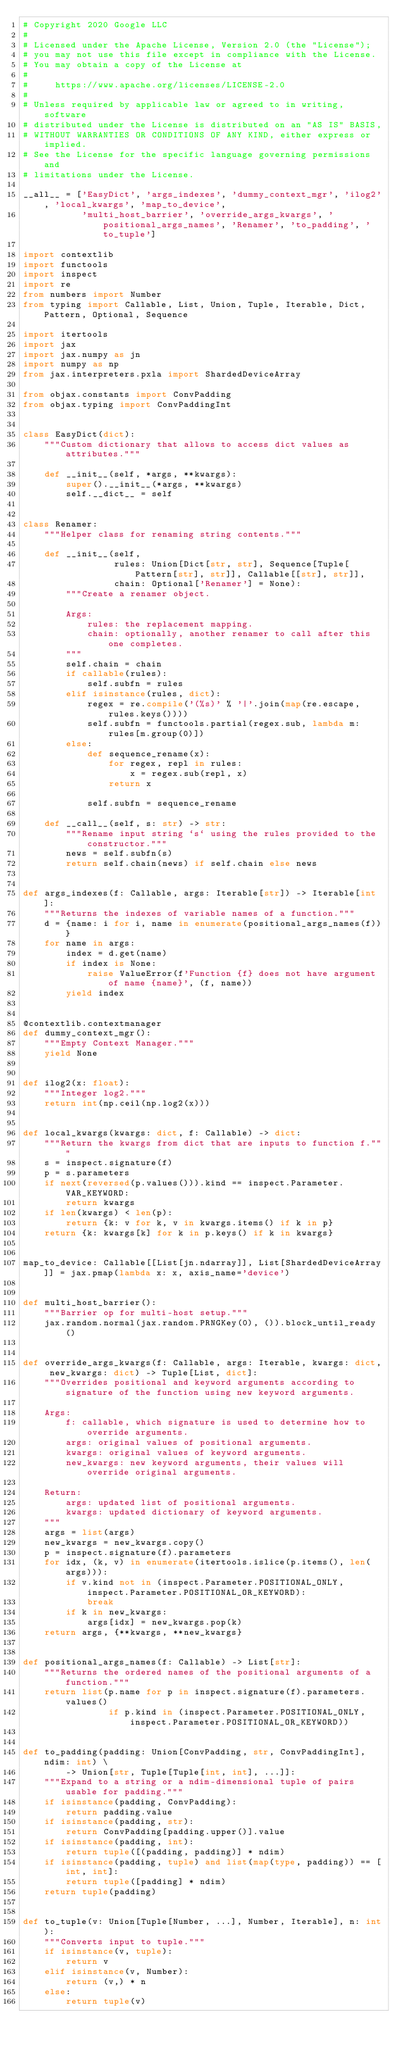Convert code to text. <code><loc_0><loc_0><loc_500><loc_500><_Python_># Copyright 2020 Google LLC
#
# Licensed under the Apache License, Version 2.0 (the "License");
# you may not use this file except in compliance with the License.
# You may obtain a copy of the License at
#
#     https://www.apache.org/licenses/LICENSE-2.0
#
# Unless required by applicable law or agreed to in writing, software
# distributed under the License is distributed on an "AS IS" BASIS,
# WITHOUT WARRANTIES OR CONDITIONS OF ANY KIND, either express or implied.
# See the License for the specific language governing permissions and
# limitations under the License.

__all__ = ['EasyDict', 'args_indexes', 'dummy_context_mgr', 'ilog2', 'local_kwargs', 'map_to_device',
           'multi_host_barrier', 'override_args_kwargs', 'positional_args_names', 'Renamer', 'to_padding', 'to_tuple']

import contextlib
import functools
import inspect
import re
from numbers import Number
from typing import Callable, List, Union, Tuple, Iterable, Dict, Pattern, Optional, Sequence

import itertools
import jax
import jax.numpy as jn
import numpy as np
from jax.interpreters.pxla import ShardedDeviceArray

from objax.constants import ConvPadding
from objax.typing import ConvPaddingInt


class EasyDict(dict):
    """Custom dictionary that allows to access dict values as attributes."""

    def __init__(self, *args, **kwargs):
        super().__init__(*args, **kwargs)
        self.__dict__ = self


class Renamer:
    """Helper class for renaming string contents."""

    def __init__(self,
                 rules: Union[Dict[str, str], Sequence[Tuple[Pattern[str], str]], Callable[[str], str]],
                 chain: Optional['Renamer'] = None):
        """Create a renamer object.

        Args:
            rules: the replacement mapping.
            chain: optionally, another renamer to call after this one completes.
        """
        self.chain = chain
        if callable(rules):
            self.subfn = rules
        elif isinstance(rules, dict):
            regex = re.compile('(%s)' % '|'.join(map(re.escape, rules.keys())))
            self.subfn = functools.partial(regex.sub, lambda m: rules[m.group(0)])
        else:
            def sequence_rename(x):
                for regex, repl in rules:
                    x = regex.sub(repl, x)
                return x

            self.subfn = sequence_rename

    def __call__(self, s: str) -> str:
        """Rename input string `s` using the rules provided to the constructor."""
        news = self.subfn(s)
        return self.chain(news) if self.chain else news


def args_indexes(f: Callable, args: Iterable[str]) -> Iterable[int]:
    """Returns the indexes of variable names of a function."""
    d = {name: i for i, name in enumerate(positional_args_names(f))}
    for name in args:
        index = d.get(name)
        if index is None:
            raise ValueError(f'Function {f} does not have argument of name {name}', (f, name))
        yield index


@contextlib.contextmanager
def dummy_context_mgr():
    """Empty Context Manager."""
    yield None


def ilog2(x: float):
    """Integer log2."""
    return int(np.ceil(np.log2(x)))


def local_kwargs(kwargs: dict, f: Callable) -> dict:
    """Return the kwargs from dict that are inputs to function f."""
    s = inspect.signature(f)
    p = s.parameters
    if next(reversed(p.values())).kind == inspect.Parameter.VAR_KEYWORD:
        return kwargs
    if len(kwargs) < len(p):
        return {k: v for k, v in kwargs.items() if k in p}
    return {k: kwargs[k] for k in p.keys() if k in kwargs}


map_to_device: Callable[[List[jn.ndarray]], List[ShardedDeviceArray]] = jax.pmap(lambda x: x, axis_name='device')


def multi_host_barrier():
    """Barrier op for multi-host setup."""
    jax.random.normal(jax.random.PRNGKey(0), ()).block_until_ready()


def override_args_kwargs(f: Callable, args: Iterable, kwargs: dict, new_kwargs: dict) -> Tuple[List, dict]:
    """Overrides positional and keyword arguments according to signature of the function using new keyword arguments.

    Args:
        f: callable, which signature is used to determine how to override arguments.
        args: original values of positional arguments.
        kwargs: original values of keyword arguments.
        new_kwargs: new keyword arguments, their values will override original arguments.

    Return:
        args: updated list of positional arguments.
        kwargs: updated dictionary of keyword arguments.
    """
    args = list(args)
    new_kwargs = new_kwargs.copy()
    p = inspect.signature(f).parameters
    for idx, (k, v) in enumerate(itertools.islice(p.items(), len(args))):
        if v.kind not in (inspect.Parameter.POSITIONAL_ONLY, inspect.Parameter.POSITIONAL_OR_KEYWORD):
            break
        if k in new_kwargs:
            args[idx] = new_kwargs.pop(k)
    return args, {**kwargs, **new_kwargs}


def positional_args_names(f: Callable) -> List[str]:
    """Returns the ordered names of the positional arguments of a function."""
    return list(p.name for p in inspect.signature(f).parameters.values()
                if p.kind in (inspect.Parameter.POSITIONAL_ONLY, inspect.Parameter.POSITIONAL_OR_KEYWORD))


def to_padding(padding: Union[ConvPadding, str, ConvPaddingInt], ndim: int) \
        -> Union[str, Tuple[Tuple[int, int], ...]]:
    """Expand to a string or a ndim-dimensional tuple of pairs usable for padding."""
    if isinstance(padding, ConvPadding):
        return padding.value
    if isinstance(padding, str):
        return ConvPadding[padding.upper()].value
    if isinstance(padding, int):
        return tuple([(padding, padding)] * ndim)
    if isinstance(padding, tuple) and list(map(type, padding)) == [int, int]:
        return tuple([padding] * ndim)
    return tuple(padding)


def to_tuple(v: Union[Tuple[Number, ...], Number, Iterable], n: int):
    """Converts input to tuple."""
    if isinstance(v, tuple):
        return v
    elif isinstance(v, Number):
        return (v,) * n
    else:
        return tuple(v)
</code> 